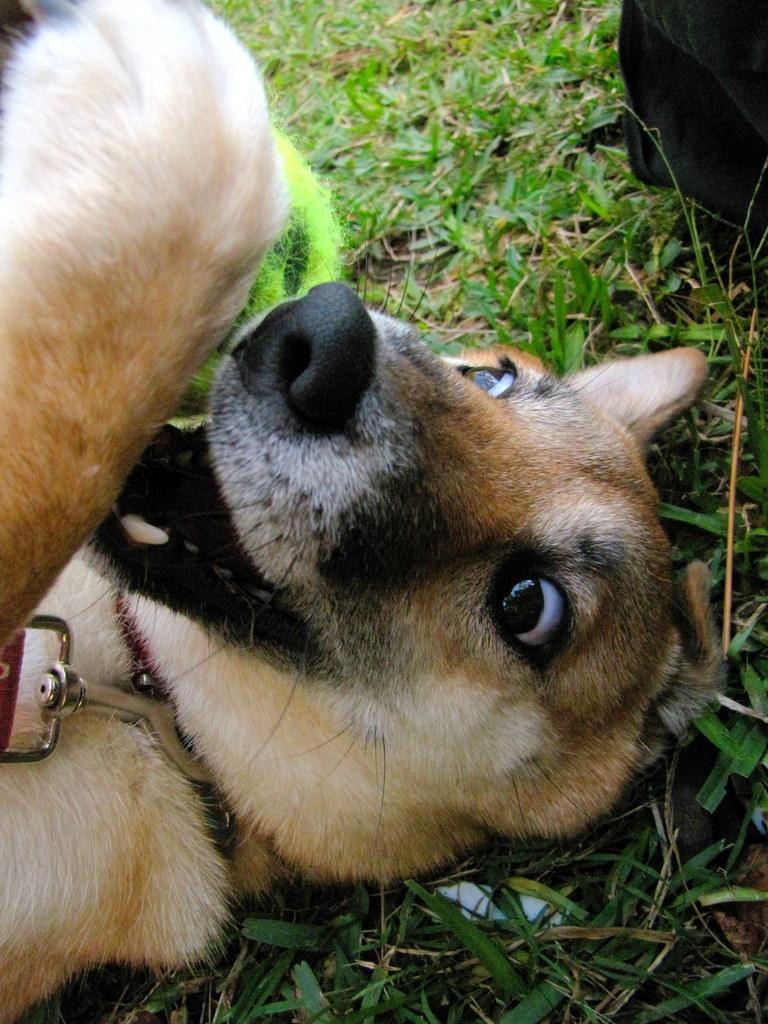What type of animal is present in the image? There is a dog in the image. What type of vegetation can be seen in the image? There is grass in the image. Can you tell me how many goats are present in the image? There are no goats present in the image; it features a dog. What type of authority figure can be seen in the image? There is no authority figure present in the image; it features a dog and grass. 